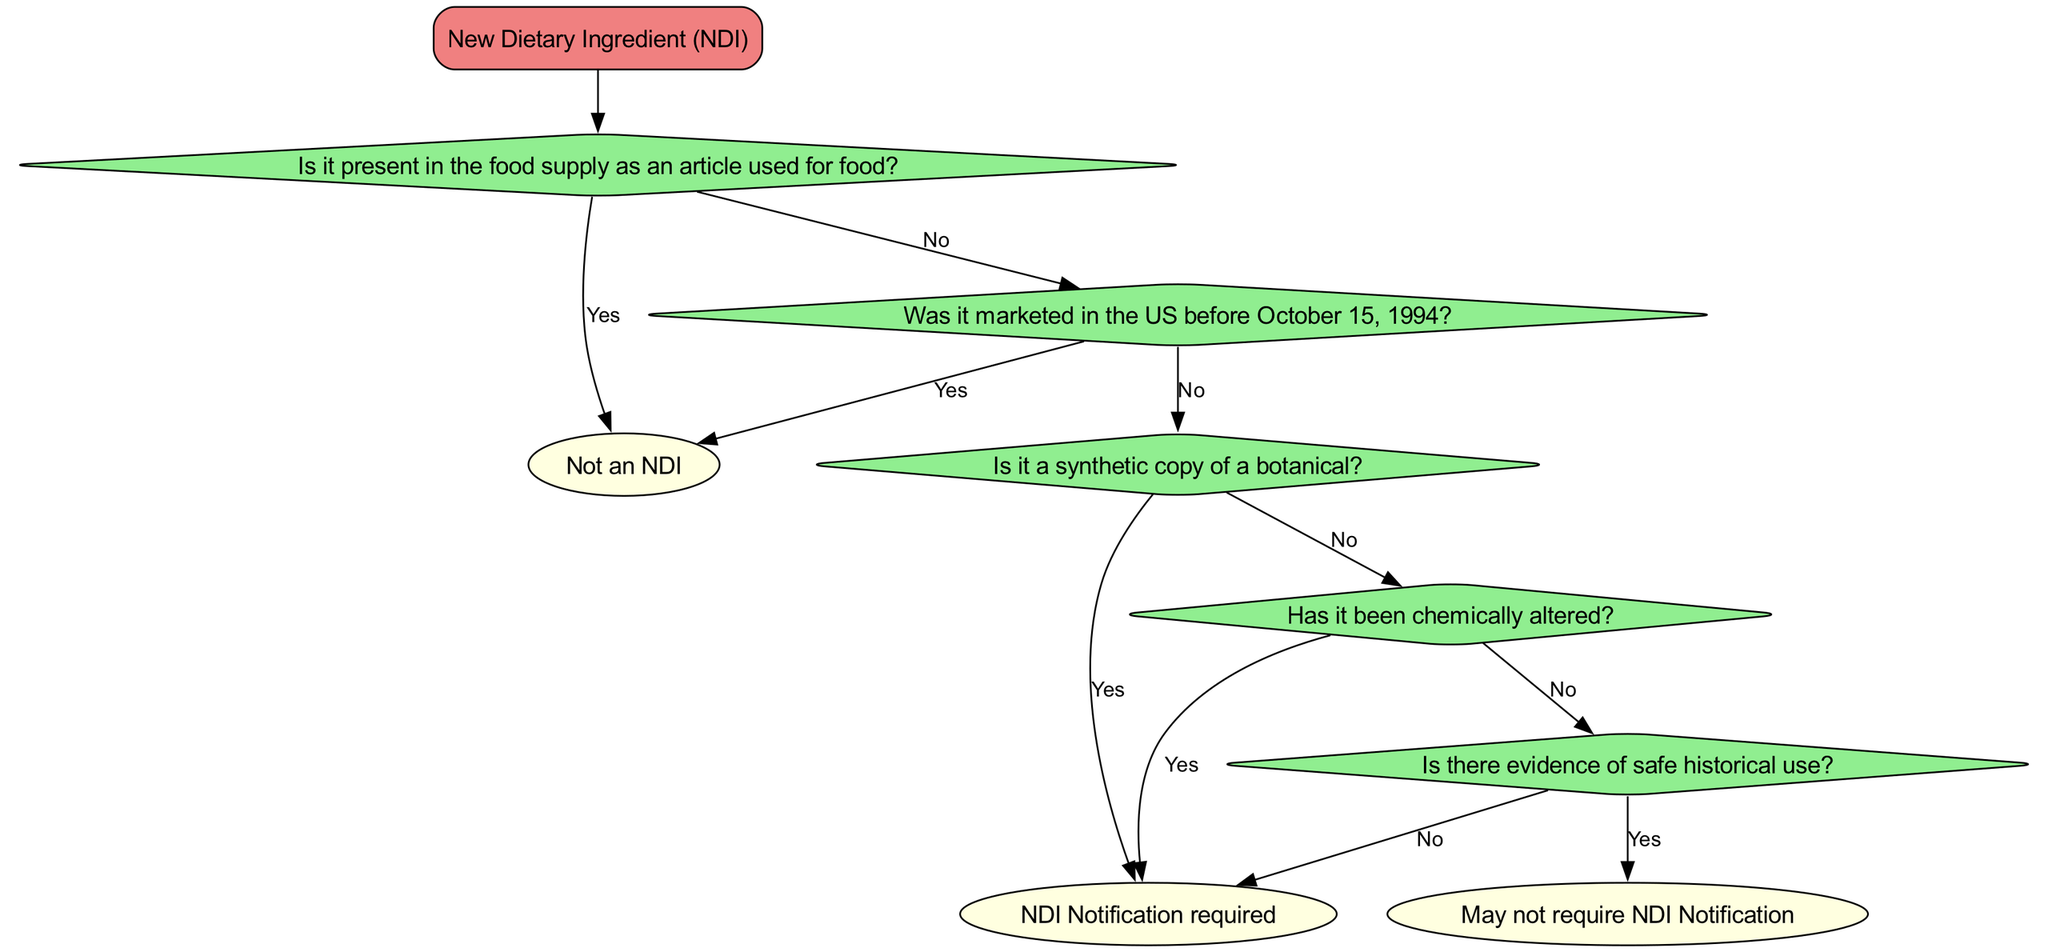What is the root node of the decision tree? The root node is the starting point of the diagram, which is labeled "New Dietary Ingredient (NDI)". It represents the main category that initiates the decision-making process related to dietary ingredients.
Answer: New Dietary Ingredient (NDI) What is the first question asked in the decision tree? The first question asked is "Is it present in the food supply as an article used for food?" This is the initial decision point that determines the pathway of the decision tree.
Answer: Is it present in the food supply as an article used for food? What is the result if the answer to the first question is 'yes'? If the answer to the first question is 'yes', the result is "Not an NDI". This indicates that the ingredient being evaluated does not fall under the category of New Dietary Ingredients.
Answer: Not an NDI How many total decisions/questions are represented in the diagram? There are a total of five decision points/questions in the diagram, including the initial question and the subsequent questions in the branches. This includes the initial question and the four follow-up questions based on different scenarios.
Answer: Five What happens if the ingredient was marketed in the US before October 15, 1994? If the ingredient was marketed in the US before October 15, 1994, the result is "Not an NDI". This follows from the second question in the decision tree regarding market history.
Answer: Not an NDI What is the conclusion if the ingredient is a synthetic copy of a botanical? If the ingredient is determined to be a synthetic copy of a botanical, the conclusion is "NDI Notification required". This means that the ingredient must go through the notification process as a new dietary ingredient.
Answer: NDI Notification required If there is evidence of safe historical use, what is the next course of action? If there is evidence of safe historical use, then it is determined that "May not require NDI Notification". This indicates that such evidence potentially alleviates the need for formal notification under regulatory guidelines.
Answer: May not require NDI Notification What will happen if the ingredient has been chemically altered? If it has been chemically altered, the outcome is "NDI Notification required". This indicates that any chemical alteration prompts the need for notification as a new dietary ingredient in the regulatory pathway.
Answer: NDI Notification required What types of ingredients would need NDI Notification according to the diagram? Ingredients that are synthetic copies of botanicals, have been chemically altered, or lack evidence of safe historical use would need NDI Notification as per the paths outlined in the diagram.
Answer: Synthetic copies, chemically altered, no safe historical use 